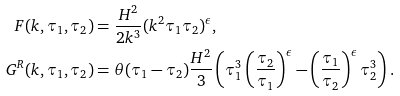<formula> <loc_0><loc_0><loc_500><loc_500>F ( k , \tau _ { 1 } , \tau _ { 2 } ) & = \frac { H ^ { 2 } } { 2 k ^ { 3 } } ( k ^ { 2 } \tau _ { 1 } \tau _ { 2 } ) ^ { \epsilon } , \\ G ^ { R } ( k , \tau _ { 1 } , \tau _ { 2 } ) & = \theta ( \tau _ { 1 } - \tau _ { 2 } ) \frac { H ^ { 2 } } { 3 } \left ( \tau _ { 1 } ^ { 3 } \left ( \frac { \tau _ { 2 } } { \tau _ { 1 } } \right ) ^ { \epsilon } - \left ( \frac { \tau _ { 1 } } { \tau _ { 2 } } \right ) ^ { \epsilon } \tau _ { 2 } ^ { 3 } \right ) .</formula> 